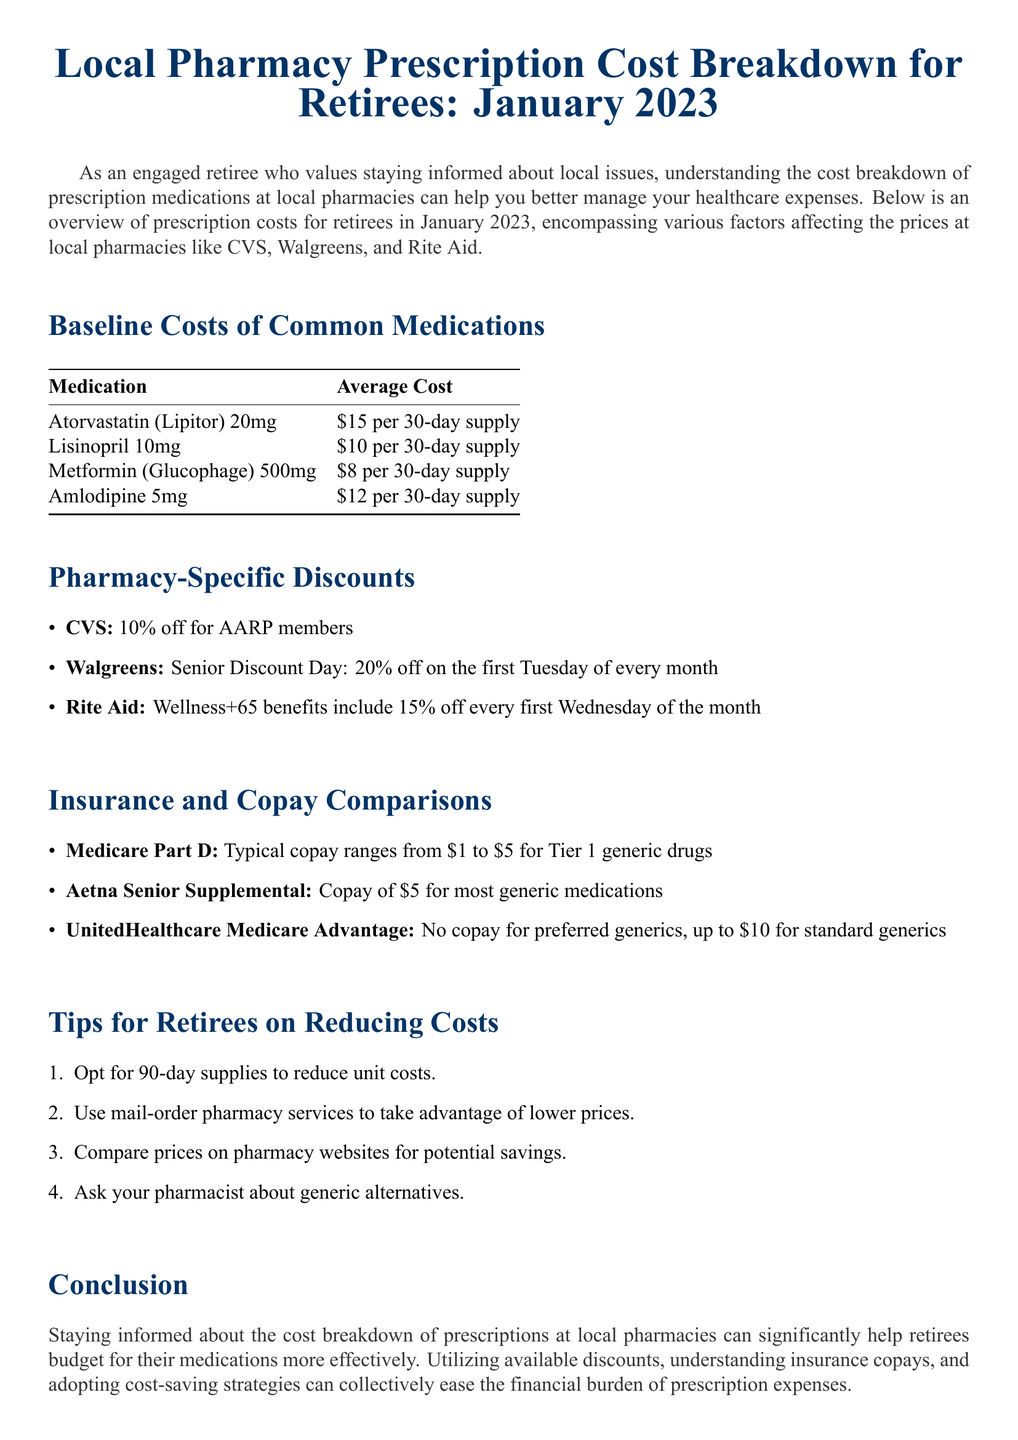What is the average cost of Atorvastatin 20mg? The average cost of Atorvastatin 20mg is specifically mentioned in the document as $15 per 30-day supply.
Answer: $15 per 30-day supply What is the discount percentage at Walgreens on Senior Discount Day? The document states that Walgreens offers a 20% off on the first Tuesday of every month for seniors.
Answer: 20% What is the copay amount for Tier 1 generic drugs under Medicare Part D? The document specifies that the typical copay for Tier 1 generic drugs ranges from $1 to $5.
Answer: $1 to $5 Which pharmacy offers a 10% discount for AARP members? The document clearly indicates that CVS offers 10% off for AARP members.
Answer: CVS What is one suggested tip for retirees to reduce prescription costs? The document lists several tips, one of which is to opt for 90-day supplies to reduce unit costs.
Answer: Opt for 90-day supplies How much is the average cost of Metformin 500mg? The specific price for Metformin (Glucophage) 500mg mentioned in the document is $8 per 30-day supply.
Answer: $8 per 30-day supply What benefits does Rite Aid's Wellness+65 program include? According to the document, Rite Aid's Wellness+65 benefits include a 15% discount every first Wednesday of the month.
Answer: 15% off What is the average cost of Amlodipine 5mg? The document specifies the average cost of Amlodipine 5mg as $12 per 30-day supply.
Answer: $12 per 30-day supply 